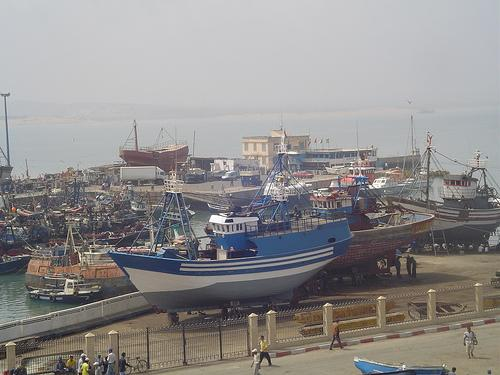Express the main sentiment or mood that the image conveys. The image conveys a busy and active atmosphere at a harbor and boat construction area with people interacting with the boats and ships. Provide a brief description of the buildings in the image. There is a large building on the edge of the harbor, a boxy building next to a flat building, and other buildings on a gray platform. List the objects mentioned in the image that are related to boats. Tall mast, boat parts, barge, railing, metal structures, and trucks are mentioned as objects related to boats in the image. How many people are explicitly mentioned walking at a boat dock? Four people are mentioned walking at a boat dock. Explain how the quality of the image is portrayed through the captions. The image quality is captured through detailed descriptions of objects, their positions, sizes, colors, and interactions between people and boats in the harbor. Identify the primary activity taking place in the image. People and workers are gathered around boats and ships in a harbor, some walking by the railing and some standing underneath a brown boat. In one sentence, describe the setting of the image. The image is set in a boat construction area near a harbor with boats, ships, people, buildings, and a mast in a muted sea, land, and sky background. Describe the interaction between people and the boats in the image. People are gathered around boats and ships, some walking by the railing, standing underneath a brown boat, and walking at the boat dock. Which object is seen on the left in the image? Tall mast Can you see a hot air balloon floating above the crowd of people? No, it's not mentioned in the image. What color is the boat with metal structures? Blue What expression is seen in the people walking by the railing? No facial expressions detected What type of building is next to the flat building in the image? Boxy building What is the color of the water near the barge? Green Can you specify if the ship is ready to be in the water or not? The ship is not ready to be in the water Are there any small boats and boat parts on a barge? Yes Describe the scene in the image with the large building near the harbor and the boats. Muted sea, land and sky behind boat construction area with buildings, boats, and people on an elevated deck. Describe the scene with the large boats near the dock. Large boats are near the large dock with workers and people around Identify the location of a person walking at a boat dock. Multiple instances - near harbor/boat area What is the color of the truck in front of the brown ship being built? Not visible or doesn't exist Create a caption that combines the elements of the gray platform, buildings, and boat. Buildings and boat on a gray platform near a large dock What are the workers doing underneath the brown boat? Standing Describe the scene where individuals are standing and walking. People standing and walking by a railing near the harbor List the colors present in the barge on green water. Gray, tan What is happening in the area with a large crowd in the image? People gathered What is the overall theme of the diagram? Boat construction area with various buildings, boats, and people What can you tell me about the location of the large building? It is on the edge of the harbor Select the right option to describe the image: A) a construction site with cranes, B) boats and people near a large dock, C) desert landscape with cactus. B) boats and people near a large dock 